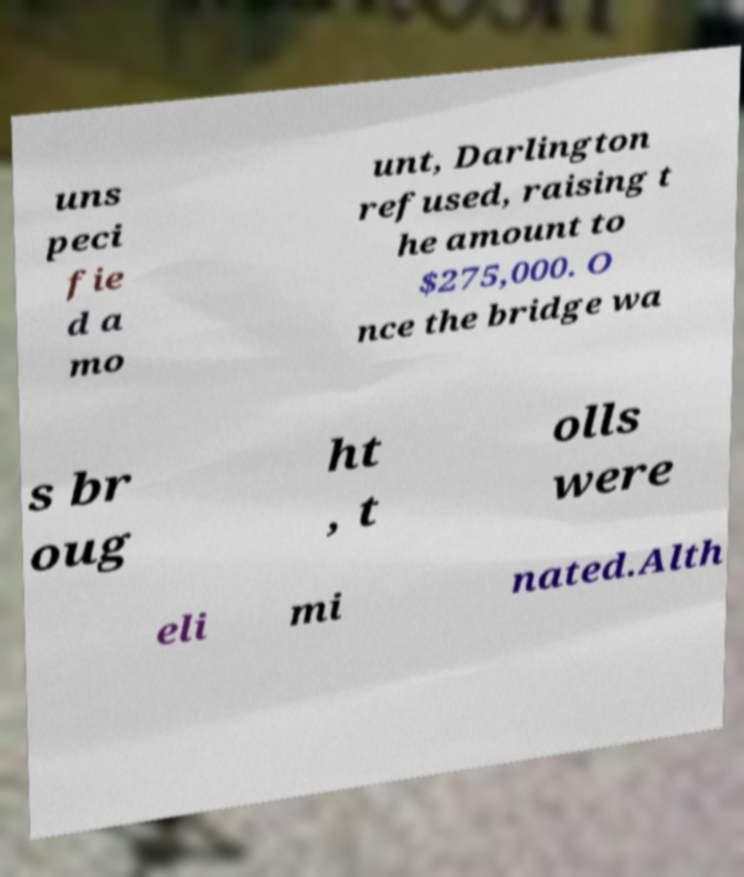Please read and relay the text visible in this image. What does it say? uns peci fie d a mo unt, Darlington refused, raising t he amount to $275,000. O nce the bridge wa s br oug ht , t olls were eli mi nated.Alth 